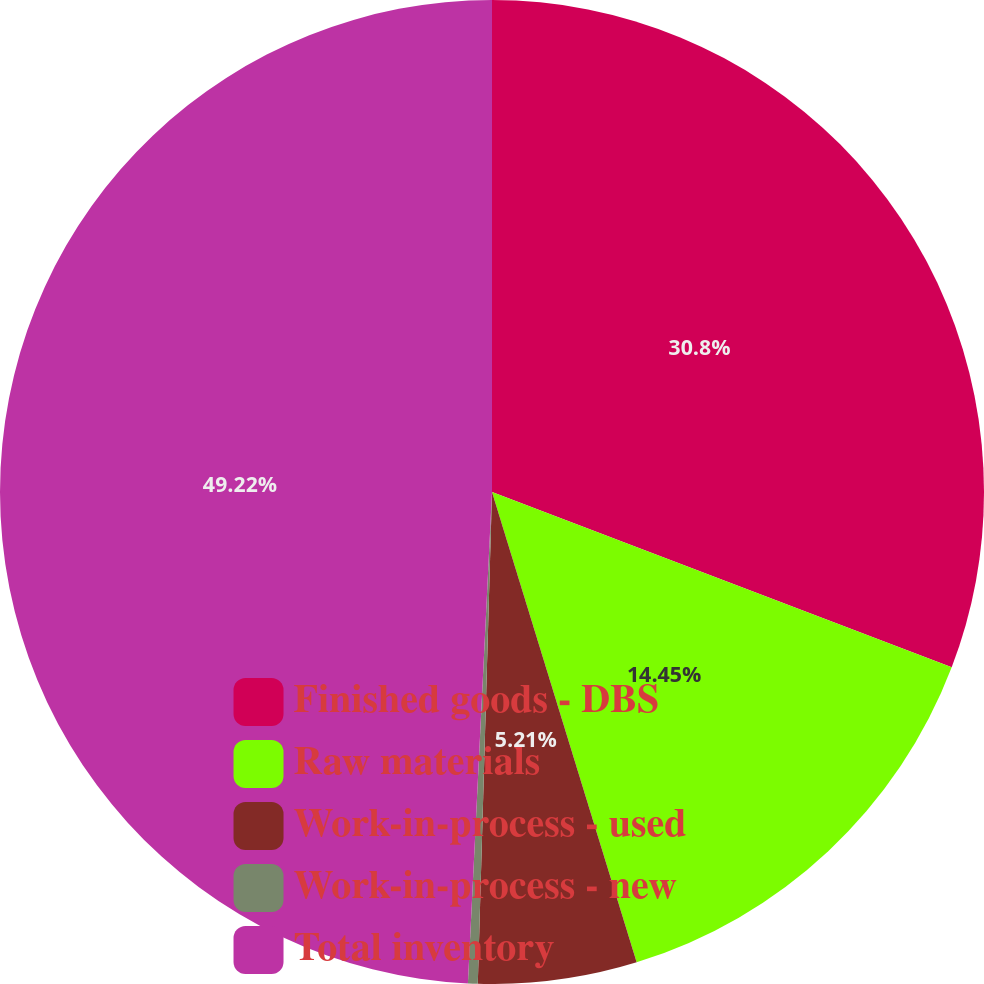Convert chart to OTSL. <chart><loc_0><loc_0><loc_500><loc_500><pie_chart><fcel>Finished goods - DBS<fcel>Raw materials<fcel>Work-in-process - used<fcel>Work-in-process - new<fcel>Total inventory<nl><fcel>30.8%<fcel>14.45%<fcel>5.21%<fcel>0.32%<fcel>49.22%<nl></chart> 